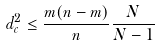Convert formula to latex. <formula><loc_0><loc_0><loc_500><loc_500>d _ { c } ^ { 2 } \leq \frac { m ( n - m ) } { n } \frac { N } { N - 1 }</formula> 